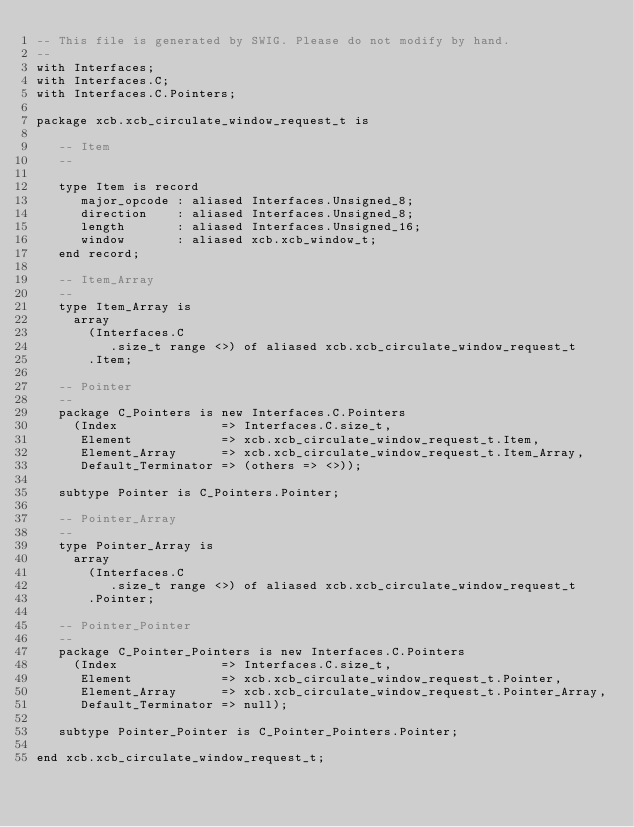Convert code to text. <code><loc_0><loc_0><loc_500><loc_500><_Ada_>-- This file is generated by SWIG. Please do not modify by hand.
--
with Interfaces;
with Interfaces.C;
with Interfaces.C.Pointers;

package xcb.xcb_circulate_window_request_t is

   -- Item
   --

   type Item is record
      major_opcode : aliased Interfaces.Unsigned_8;
      direction    : aliased Interfaces.Unsigned_8;
      length       : aliased Interfaces.Unsigned_16;
      window       : aliased xcb.xcb_window_t;
   end record;

   -- Item_Array
   --
   type Item_Array is
     array
       (Interfaces.C
          .size_t range <>) of aliased xcb.xcb_circulate_window_request_t
       .Item;

   -- Pointer
   --
   package C_Pointers is new Interfaces.C.Pointers
     (Index              => Interfaces.C.size_t,
      Element            => xcb.xcb_circulate_window_request_t.Item,
      Element_Array      => xcb.xcb_circulate_window_request_t.Item_Array,
      Default_Terminator => (others => <>));

   subtype Pointer is C_Pointers.Pointer;

   -- Pointer_Array
   --
   type Pointer_Array is
     array
       (Interfaces.C
          .size_t range <>) of aliased xcb.xcb_circulate_window_request_t
       .Pointer;

   -- Pointer_Pointer
   --
   package C_Pointer_Pointers is new Interfaces.C.Pointers
     (Index              => Interfaces.C.size_t,
      Element            => xcb.xcb_circulate_window_request_t.Pointer,
      Element_Array      => xcb.xcb_circulate_window_request_t.Pointer_Array,
      Default_Terminator => null);

   subtype Pointer_Pointer is C_Pointer_Pointers.Pointer;

end xcb.xcb_circulate_window_request_t;
</code> 